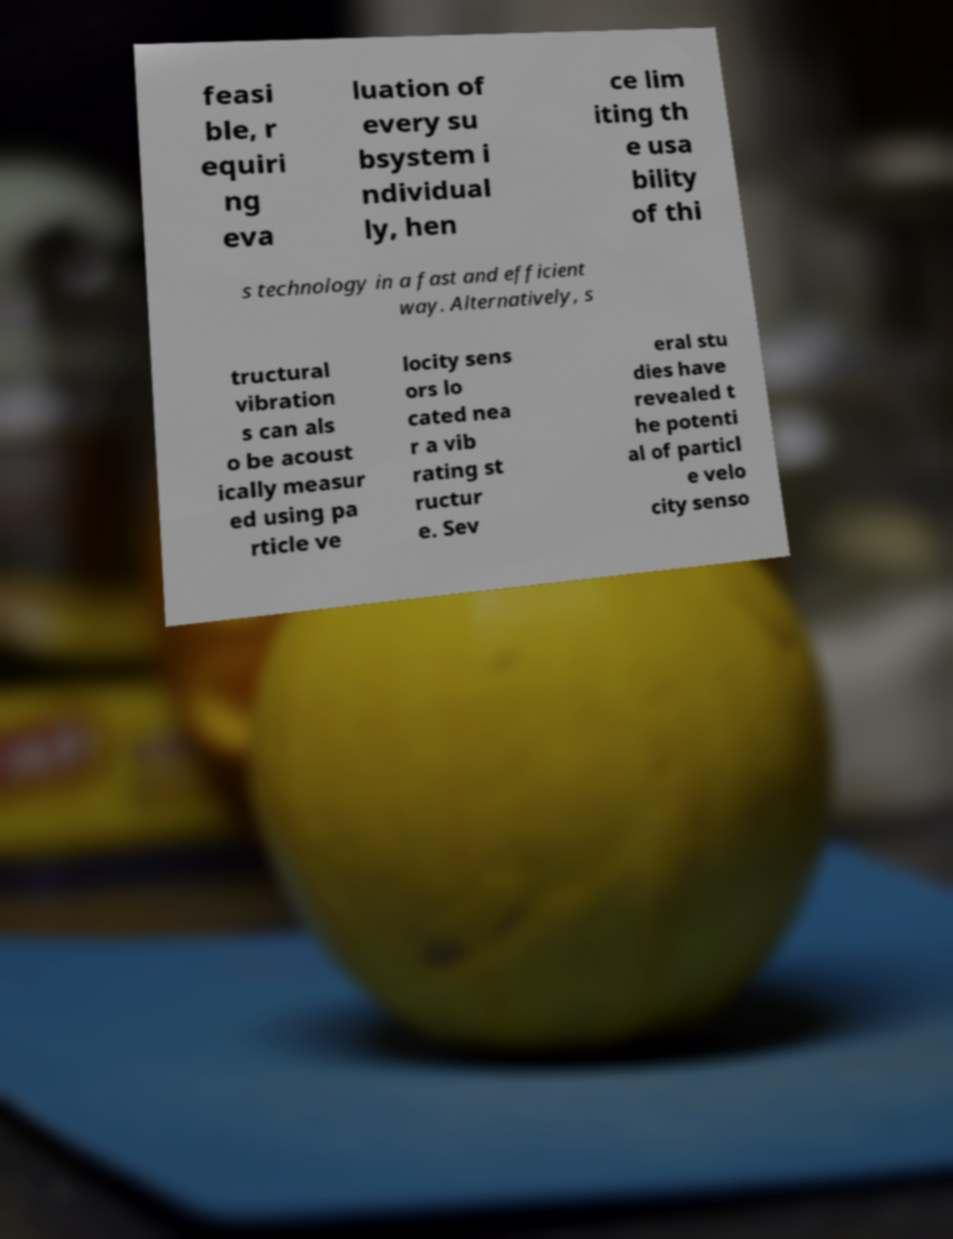Could you extract and type out the text from this image? feasi ble, r equiri ng eva luation of every su bsystem i ndividual ly, hen ce lim iting th e usa bility of thi s technology in a fast and efficient way. Alternatively, s tructural vibration s can als o be acoust ically measur ed using pa rticle ve locity sens ors lo cated nea r a vib rating st ructur e. Sev eral stu dies have revealed t he potenti al of particl e velo city senso 